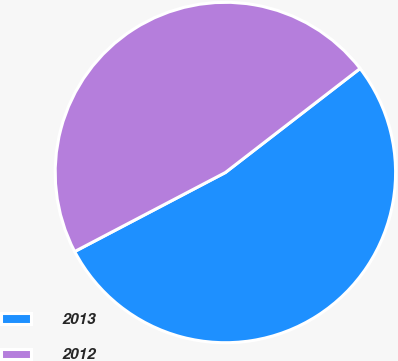Convert chart to OTSL. <chart><loc_0><loc_0><loc_500><loc_500><pie_chart><fcel>2013<fcel>2012<nl><fcel>52.78%<fcel>47.22%<nl></chart> 